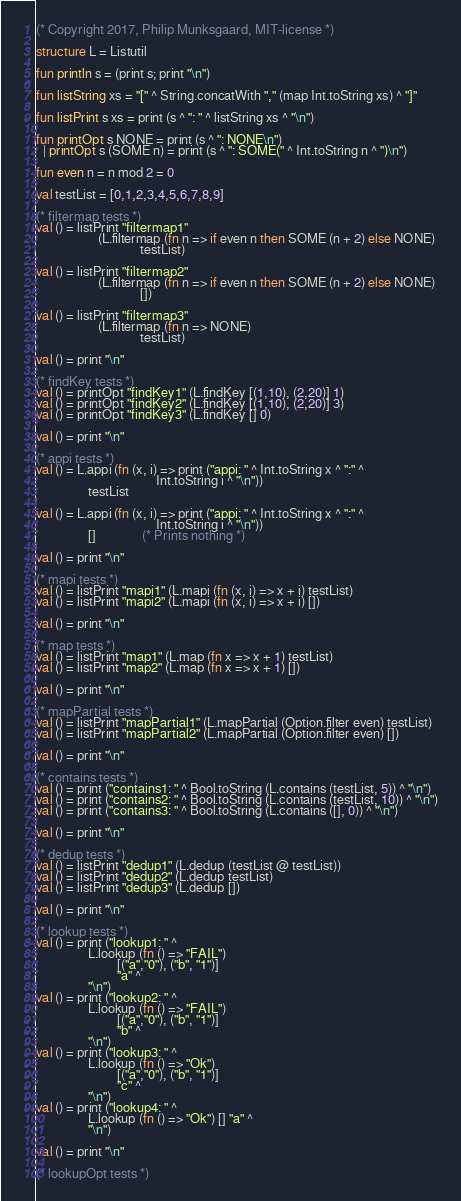Convert code to text. <code><loc_0><loc_0><loc_500><loc_500><_SML_>(* Copyright 2017, Philip Munksgaard, MIT-license *)

structure L = Listutil

fun println s = (print s; print "\n")

fun listString xs = "[" ^ String.concatWith "," (map Int.toString xs) ^ "]"

fun listPrint s xs = print (s ^ ": " ^ listString xs ^ "\n")

fun printOpt s NONE = print (s ^ ": NONE\n")
  | printOpt s (SOME n) = print (s ^ ": SOME(" ^ Int.toString n ^ ")\n")

fun even n = n mod 2 = 0

val testList = [0,1,2,3,4,5,6,7,8,9]

(* filtermap tests *)
val () = listPrint "filtermap1"
                   (L.filtermap (fn n => if even n then SOME (n + 2) else NONE)
                                testList)

val () = listPrint "filtermap2"
                   (L.filtermap (fn n => if even n then SOME (n + 2) else NONE)
                                [])

val () = listPrint "filtermap3"
                   (L.filtermap (fn n => NONE)
                                testList)

val () = print "\n"

(* findKey tests *)
val () = printOpt "findKey1" (L.findKey [(1,10), (2,20)] 1)
val () = printOpt "findKey2" (L.findKey [(1,10), (2,20)] 3)
val () = printOpt "findKey3" (L.findKey [] 0)

val () = print "\n"

(* appi tests *)
val () = L.appi (fn (x, i) => print ("appi: " ^ Int.toString x ^ ":" ^
                                     Int.toString i ^ "\n"))
                testList

val () = L.appi (fn (x, i) => print ("appi: " ^ Int.toString x ^ ":" ^
                                     Int.toString i ^ "\n"))
                []              (* Prints nothing *)

val () = print "\n"

(* mapi tests *)
val () = listPrint "mapi1" (L.mapi (fn (x, i) => x + i) testList)
val () = listPrint "mapi2" (L.mapi (fn (x, i) => x + i) [])

val () = print "\n"

(* map tests *)
val () = listPrint "map1" (L.map (fn x => x + 1) testList)
val () = listPrint "map2" (L.map (fn x => x + 1) [])

val () = print "\n"

(* mapPartial tests *)
val () = listPrint "mapPartial1" (L.mapPartial (Option.filter even) testList)
val () = listPrint "mapPartial2" (L.mapPartial (Option.filter even) [])

val () = print "\n"

(* contains tests *)
val () = print ("contains1: " ^ Bool.toString (L.contains (testList, 5)) ^ "\n")
val () = print ("contains2: " ^ Bool.toString (L.contains (testList, 10)) ^ "\n")
val () = print ("contains3: " ^ Bool.toString (L.contains ([], 0)) ^ "\n")

val () = print "\n"

(* dedup tests *)
val () = listPrint "dedup1" (L.dedup (testList @ testList))
val () = listPrint "dedup2" (L.dedup testList)
val () = listPrint "dedup3" (L.dedup [])

val () = print "\n"

(* lookup tests *)
val () = print ("lookup1: " ^
                L.lookup (fn () => "FAIL")
                         [("a","0"), ("b", "1")]
                         "a" ^
                "\n")
val () = print ("lookup2: " ^
                L.lookup (fn () => "FAIL")
                         [("a","0"), ("b", "1")]
                         "b" ^
                "\n")
val () = print ("lookup3: " ^
                L.lookup (fn () => "Ok")
                         [("a","0"), ("b", "1")]
                         "c" ^
                "\n")
val () = print ("lookup4: " ^
                L.lookup (fn () => "Ok") [] "a" ^
                "\n")

val () = print "\n"

(* lookupOpt tests *)</code> 